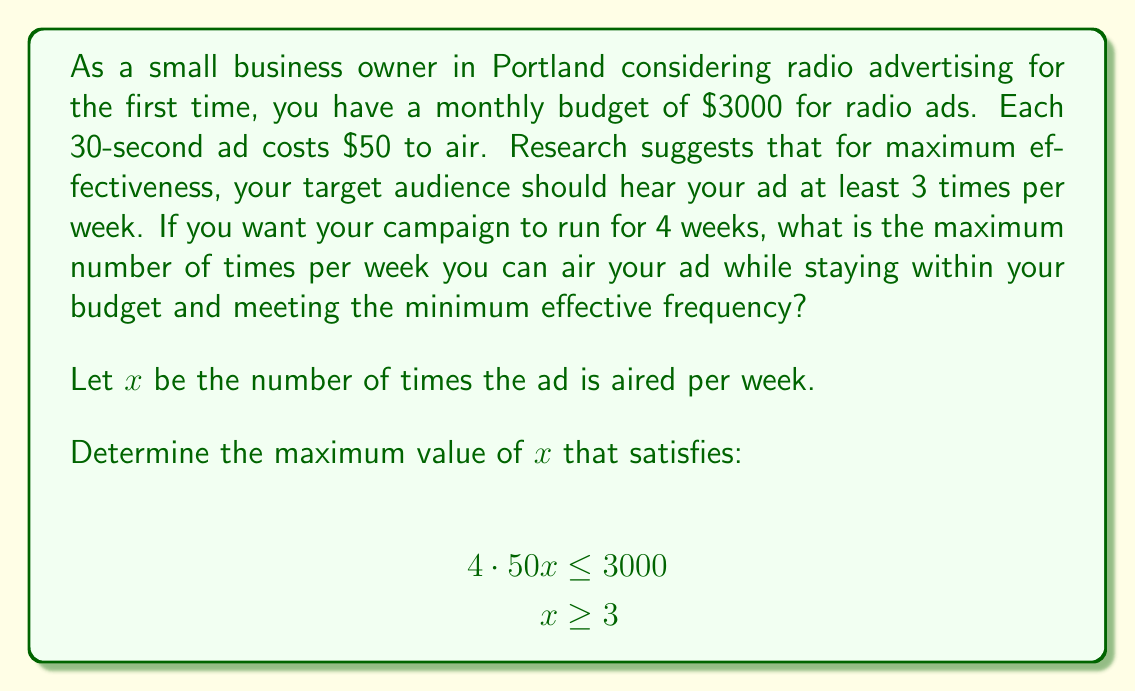What is the answer to this math problem? Let's approach this step-by-step:

1) First, let's understand what the inequality $4 \cdot 50x \leq 3000$ means:
   - $50x$ is the cost of airing the ad $x$ times in one week
   - $4 \cdot 50x$ is the cost for 4 weeks
   - This should be less than or equal to the budget of $3000

2) Simplify the inequality:
   $$200x \leq 3000$$

3) Solve for $x$:
   $$x \leq \frac{3000}{200} = 15$$

4) However, we also have the constraint that $x \geq 3$ for effectiveness.

5) Combining these conditions, we have:
   $$3 \leq x \leq 15$$

6) Since we're looking for the maximum value of $x$, we choose the upper bound.

7) To ensure we're using an integer number of ads, we round down to 15.

Therefore, the maximum number of times the ad can be aired per week is 15.
Answer: The maximum number of times the ad can be aired per week while staying within budget and meeting the minimum effective frequency is 15. 